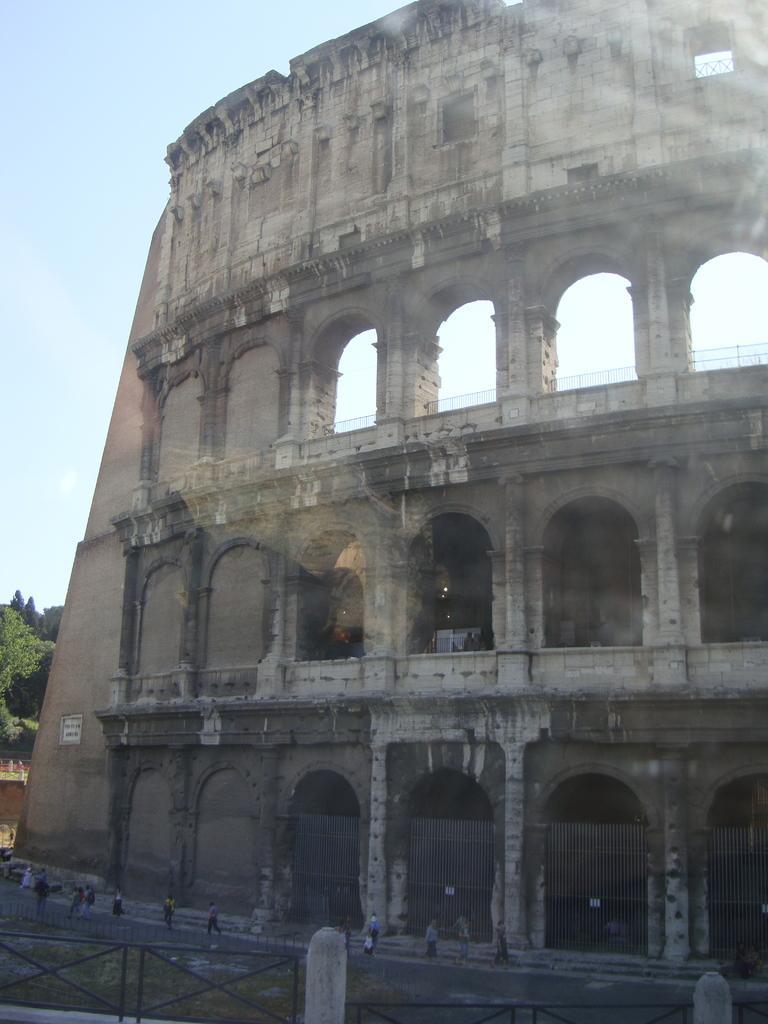Can you describe this image briefly? In this image we can see a building with arches and pillars. Also there are railings. And there are many people. In the background there is sky. 